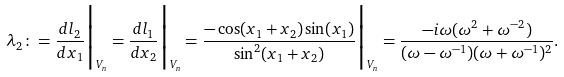<formula> <loc_0><loc_0><loc_500><loc_500>\lambda _ { 2 } \colon = \frac { d l _ { 2 } } { d x _ { 1 } } \Big | _ { V _ { n } } = \frac { d l _ { 1 } } { d x _ { 2 } } \Big | _ { V _ { n } } = \frac { - \cos ( x _ { 1 } + x _ { 2 } ) \sin ( x _ { 1 } ) } { \sin ^ { 2 } ( x _ { 1 } + x _ { 2 } ) } \Big | _ { V _ { n } } = \frac { - i \omega ( \omega ^ { 2 } + \omega ^ { - 2 } ) } { ( \omega - \omega ^ { - 1 } ) ( \omega + \omega ^ { - 1 } ) ^ { 2 } } .</formula> 